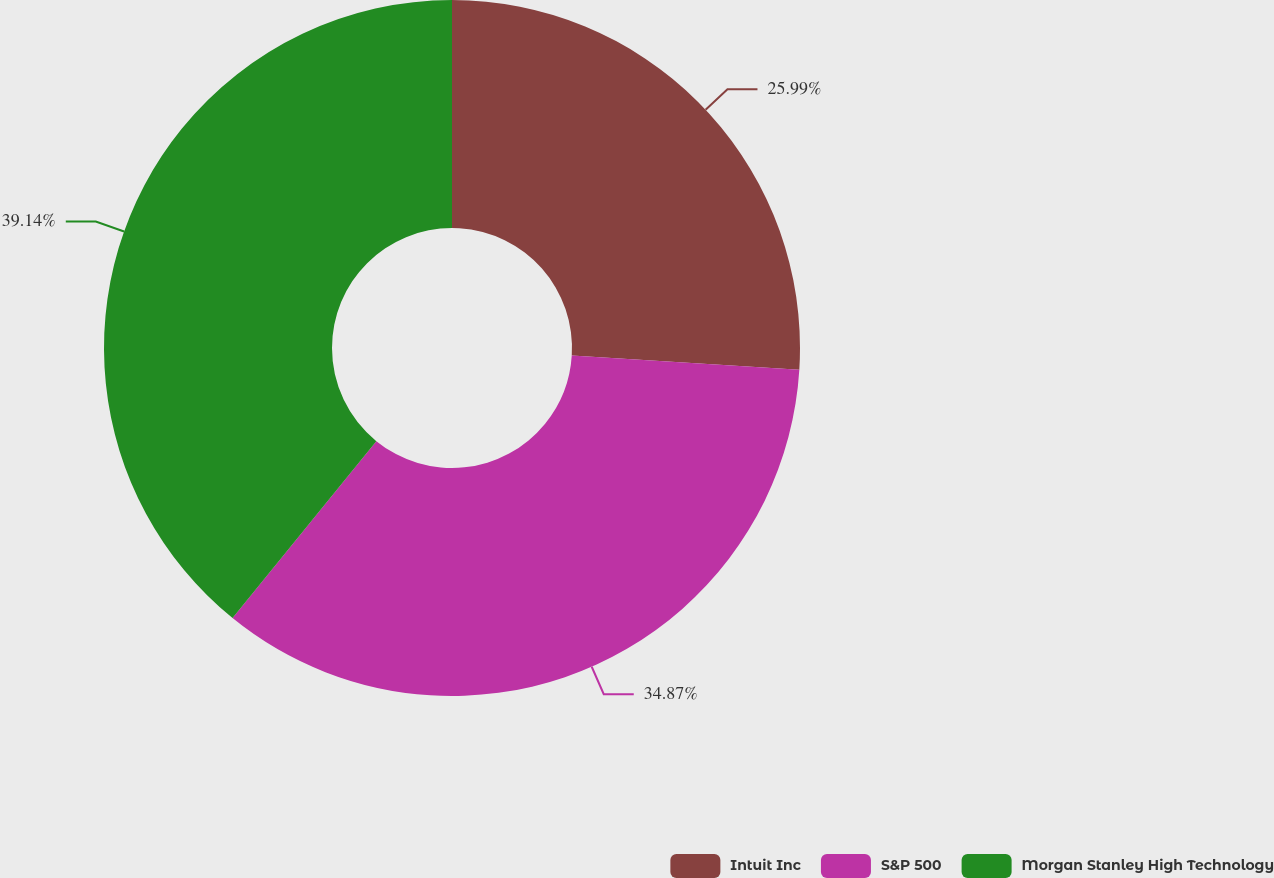Convert chart to OTSL. <chart><loc_0><loc_0><loc_500><loc_500><pie_chart><fcel>Intuit Inc<fcel>S&P 500<fcel>Morgan Stanley High Technology<nl><fcel>25.99%<fcel>34.87%<fcel>39.14%<nl></chart> 